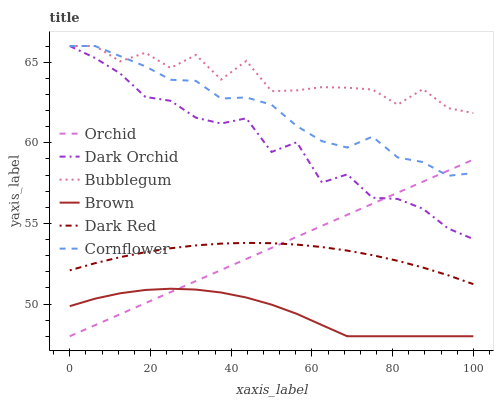Does Brown have the minimum area under the curve?
Answer yes or no. Yes. Does Bubblegum have the maximum area under the curve?
Answer yes or no. Yes. Does Dark Red have the minimum area under the curve?
Answer yes or no. No. Does Dark Red have the maximum area under the curve?
Answer yes or no. No. Is Orchid the smoothest?
Answer yes or no. Yes. Is Bubblegum the roughest?
Answer yes or no. Yes. Is Brown the smoothest?
Answer yes or no. No. Is Brown the roughest?
Answer yes or no. No. Does Brown have the lowest value?
Answer yes or no. Yes. Does Dark Red have the lowest value?
Answer yes or no. No. Does Dark Orchid have the highest value?
Answer yes or no. Yes. Does Dark Red have the highest value?
Answer yes or no. No. Is Brown less than Dark Orchid?
Answer yes or no. Yes. Is Cornflower greater than Brown?
Answer yes or no. Yes. Does Cornflower intersect Orchid?
Answer yes or no. Yes. Is Cornflower less than Orchid?
Answer yes or no. No. Is Cornflower greater than Orchid?
Answer yes or no. No. Does Brown intersect Dark Orchid?
Answer yes or no. No. 